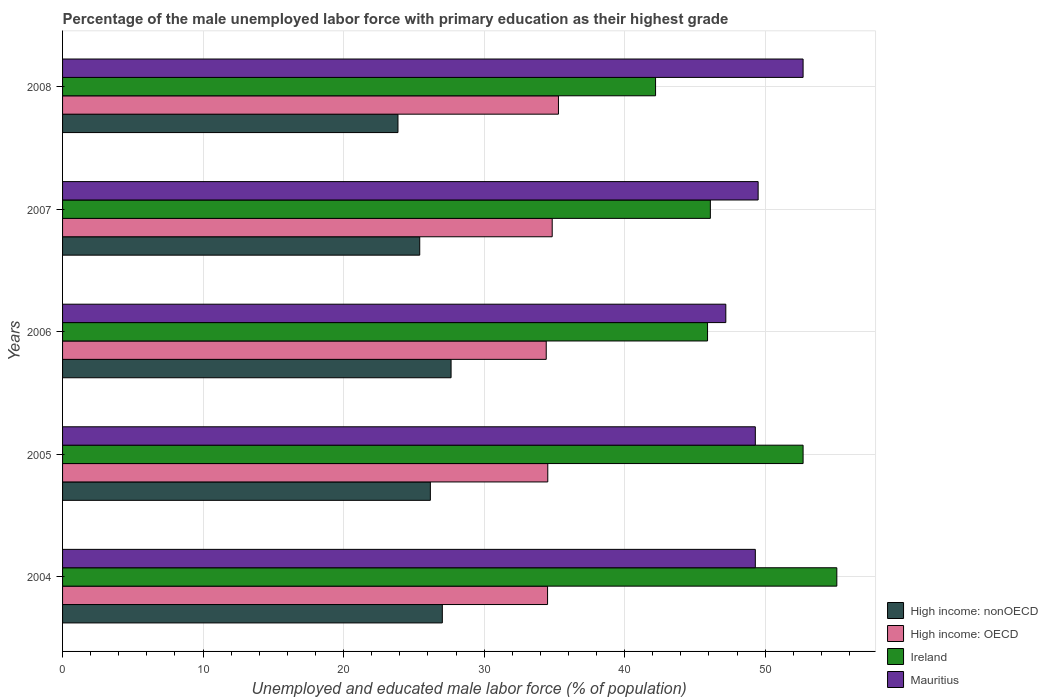How many groups of bars are there?
Keep it short and to the point. 5. Are the number of bars per tick equal to the number of legend labels?
Your answer should be compact. Yes. Are the number of bars on each tick of the Y-axis equal?
Provide a short and direct response. Yes. How many bars are there on the 1st tick from the top?
Your answer should be very brief. 4. What is the label of the 3rd group of bars from the top?
Provide a short and direct response. 2006. What is the percentage of the unemployed male labor force with primary education in High income: OECD in 2005?
Your answer should be compact. 34.53. Across all years, what is the maximum percentage of the unemployed male labor force with primary education in Ireland?
Your answer should be compact. 55.1. Across all years, what is the minimum percentage of the unemployed male labor force with primary education in High income: OECD?
Provide a short and direct response. 34.42. What is the total percentage of the unemployed male labor force with primary education in High income: OECD in the graph?
Offer a terse response. 173.6. What is the difference between the percentage of the unemployed male labor force with primary education in High income: OECD in 2007 and that in 2008?
Your response must be concise. -0.45. What is the difference between the percentage of the unemployed male labor force with primary education in Mauritius in 2006 and the percentage of the unemployed male labor force with primary education in High income: nonOECD in 2008?
Ensure brevity in your answer.  23.33. What is the average percentage of the unemployed male labor force with primary education in High income: nonOECD per year?
Keep it short and to the point. 26.03. In the year 2006, what is the difference between the percentage of the unemployed male labor force with primary education in Ireland and percentage of the unemployed male labor force with primary education in High income: nonOECD?
Offer a terse response. 18.25. What is the ratio of the percentage of the unemployed male labor force with primary education in High income: nonOECD in 2004 to that in 2007?
Ensure brevity in your answer.  1.06. Is the percentage of the unemployed male labor force with primary education in High income: nonOECD in 2006 less than that in 2007?
Provide a short and direct response. No. Is the difference between the percentage of the unemployed male labor force with primary education in Ireland in 2004 and 2008 greater than the difference between the percentage of the unemployed male labor force with primary education in High income: nonOECD in 2004 and 2008?
Ensure brevity in your answer.  Yes. What is the difference between the highest and the second highest percentage of the unemployed male labor force with primary education in Mauritius?
Provide a succinct answer. 3.2. What is the difference between the highest and the lowest percentage of the unemployed male labor force with primary education in High income: nonOECD?
Give a very brief answer. 3.78. In how many years, is the percentage of the unemployed male labor force with primary education in Ireland greater than the average percentage of the unemployed male labor force with primary education in Ireland taken over all years?
Make the answer very short. 2. Is it the case that in every year, the sum of the percentage of the unemployed male labor force with primary education in High income: nonOECD and percentage of the unemployed male labor force with primary education in Mauritius is greater than the sum of percentage of the unemployed male labor force with primary education in High income: OECD and percentage of the unemployed male labor force with primary education in Ireland?
Offer a terse response. Yes. What does the 4th bar from the top in 2006 represents?
Your answer should be compact. High income: nonOECD. What does the 2nd bar from the bottom in 2004 represents?
Your answer should be compact. High income: OECD. Are all the bars in the graph horizontal?
Your answer should be very brief. Yes. What is the difference between two consecutive major ticks on the X-axis?
Provide a succinct answer. 10. Does the graph contain grids?
Offer a terse response. Yes. How many legend labels are there?
Your answer should be compact. 4. What is the title of the graph?
Keep it short and to the point. Percentage of the male unemployed labor force with primary education as their highest grade. Does "Small states" appear as one of the legend labels in the graph?
Offer a terse response. No. What is the label or title of the X-axis?
Keep it short and to the point. Unemployed and educated male labor force (% of population). What is the Unemployed and educated male labor force (% of population) in High income: nonOECD in 2004?
Provide a short and direct response. 27.03. What is the Unemployed and educated male labor force (% of population) of High income: OECD in 2004?
Offer a terse response. 34.51. What is the Unemployed and educated male labor force (% of population) of Ireland in 2004?
Provide a short and direct response. 55.1. What is the Unemployed and educated male labor force (% of population) of Mauritius in 2004?
Give a very brief answer. 49.3. What is the Unemployed and educated male labor force (% of population) of High income: nonOECD in 2005?
Your answer should be very brief. 26.17. What is the Unemployed and educated male labor force (% of population) in High income: OECD in 2005?
Provide a short and direct response. 34.53. What is the Unemployed and educated male labor force (% of population) of Ireland in 2005?
Make the answer very short. 52.7. What is the Unemployed and educated male labor force (% of population) of Mauritius in 2005?
Offer a terse response. 49.3. What is the Unemployed and educated male labor force (% of population) in High income: nonOECD in 2006?
Keep it short and to the point. 27.65. What is the Unemployed and educated male labor force (% of population) of High income: OECD in 2006?
Your answer should be very brief. 34.42. What is the Unemployed and educated male labor force (% of population) in Ireland in 2006?
Provide a succinct answer. 45.9. What is the Unemployed and educated male labor force (% of population) of Mauritius in 2006?
Your response must be concise. 47.2. What is the Unemployed and educated male labor force (% of population) of High income: nonOECD in 2007?
Ensure brevity in your answer.  25.42. What is the Unemployed and educated male labor force (% of population) in High income: OECD in 2007?
Your answer should be very brief. 34.84. What is the Unemployed and educated male labor force (% of population) in Ireland in 2007?
Make the answer very short. 46.1. What is the Unemployed and educated male labor force (% of population) in Mauritius in 2007?
Ensure brevity in your answer.  49.5. What is the Unemployed and educated male labor force (% of population) of High income: nonOECD in 2008?
Offer a very short reply. 23.87. What is the Unemployed and educated male labor force (% of population) in High income: OECD in 2008?
Make the answer very short. 35.29. What is the Unemployed and educated male labor force (% of population) of Ireland in 2008?
Provide a short and direct response. 42.2. What is the Unemployed and educated male labor force (% of population) of Mauritius in 2008?
Offer a terse response. 52.7. Across all years, what is the maximum Unemployed and educated male labor force (% of population) of High income: nonOECD?
Your answer should be compact. 27.65. Across all years, what is the maximum Unemployed and educated male labor force (% of population) of High income: OECD?
Ensure brevity in your answer.  35.29. Across all years, what is the maximum Unemployed and educated male labor force (% of population) in Ireland?
Your answer should be compact. 55.1. Across all years, what is the maximum Unemployed and educated male labor force (% of population) in Mauritius?
Provide a short and direct response. 52.7. Across all years, what is the minimum Unemployed and educated male labor force (% of population) in High income: nonOECD?
Your response must be concise. 23.87. Across all years, what is the minimum Unemployed and educated male labor force (% of population) in High income: OECD?
Provide a short and direct response. 34.42. Across all years, what is the minimum Unemployed and educated male labor force (% of population) of Ireland?
Your response must be concise. 42.2. Across all years, what is the minimum Unemployed and educated male labor force (% of population) in Mauritius?
Your response must be concise. 47.2. What is the total Unemployed and educated male labor force (% of population) of High income: nonOECD in the graph?
Your answer should be compact. 130.13. What is the total Unemployed and educated male labor force (% of population) in High income: OECD in the graph?
Make the answer very short. 173.6. What is the total Unemployed and educated male labor force (% of population) of Ireland in the graph?
Your answer should be compact. 242. What is the total Unemployed and educated male labor force (% of population) of Mauritius in the graph?
Ensure brevity in your answer.  248. What is the difference between the Unemployed and educated male labor force (% of population) of High income: nonOECD in 2004 and that in 2005?
Your answer should be very brief. 0.85. What is the difference between the Unemployed and educated male labor force (% of population) in High income: OECD in 2004 and that in 2005?
Ensure brevity in your answer.  -0.02. What is the difference between the Unemployed and educated male labor force (% of population) in Mauritius in 2004 and that in 2005?
Your answer should be very brief. 0. What is the difference between the Unemployed and educated male labor force (% of population) of High income: nonOECD in 2004 and that in 2006?
Provide a succinct answer. -0.62. What is the difference between the Unemployed and educated male labor force (% of population) of High income: OECD in 2004 and that in 2006?
Offer a terse response. 0.09. What is the difference between the Unemployed and educated male labor force (% of population) of Ireland in 2004 and that in 2006?
Give a very brief answer. 9.2. What is the difference between the Unemployed and educated male labor force (% of population) in High income: nonOECD in 2004 and that in 2007?
Your answer should be compact. 1.61. What is the difference between the Unemployed and educated male labor force (% of population) in High income: OECD in 2004 and that in 2007?
Your response must be concise. -0.33. What is the difference between the Unemployed and educated male labor force (% of population) of Ireland in 2004 and that in 2007?
Make the answer very short. 9. What is the difference between the Unemployed and educated male labor force (% of population) of Mauritius in 2004 and that in 2007?
Offer a very short reply. -0.2. What is the difference between the Unemployed and educated male labor force (% of population) of High income: nonOECD in 2004 and that in 2008?
Ensure brevity in your answer.  3.16. What is the difference between the Unemployed and educated male labor force (% of population) of High income: OECD in 2004 and that in 2008?
Your answer should be compact. -0.78. What is the difference between the Unemployed and educated male labor force (% of population) in Ireland in 2004 and that in 2008?
Offer a terse response. 12.9. What is the difference between the Unemployed and educated male labor force (% of population) in Mauritius in 2004 and that in 2008?
Keep it short and to the point. -3.4. What is the difference between the Unemployed and educated male labor force (% of population) in High income: nonOECD in 2005 and that in 2006?
Your answer should be compact. -1.47. What is the difference between the Unemployed and educated male labor force (% of population) of High income: OECD in 2005 and that in 2006?
Make the answer very short. 0.11. What is the difference between the Unemployed and educated male labor force (% of population) in High income: nonOECD in 2005 and that in 2007?
Make the answer very short. 0.76. What is the difference between the Unemployed and educated male labor force (% of population) in High income: OECD in 2005 and that in 2007?
Ensure brevity in your answer.  -0.31. What is the difference between the Unemployed and educated male labor force (% of population) in Mauritius in 2005 and that in 2007?
Your answer should be very brief. -0.2. What is the difference between the Unemployed and educated male labor force (% of population) of High income: nonOECD in 2005 and that in 2008?
Your answer should be compact. 2.31. What is the difference between the Unemployed and educated male labor force (% of population) in High income: OECD in 2005 and that in 2008?
Your response must be concise. -0.76. What is the difference between the Unemployed and educated male labor force (% of population) in Mauritius in 2005 and that in 2008?
Provide a short and direct response. -3.4. What is the difference between the Unemployed and educated male labor force (% of population) in High income: nonOECD in 2006 and that in 2007?
Ensure brevity in your answer.  2.23. What is the difference between the Unemployed and educated male labor force (% of population) of High income: OECD in 2006 and that in 2007?
Offer a terse response. -0.42. What is the difference between the Unemployed and educated male labor force (% of population) of High income: nonOECD in 2006 and that in 2008?
Provide a succinct answer. 3.78. What is the difference between the Unemployed and educated male labor force (% of population) of High income: OECD in 2006 and that in 2008?
Provide a succinct answer. -0.87. What is the difference between the Unemployed and educated male labor force (% of population) in Ireland in 2006 and that in 2008?
Make the answer very short. 3.7. What is the difference between the Unemployed and educated male labor force (% of population) in Mauritius in 2006 and that in 2008?
Provide a short and direct response. -5.5. What is the difference between the Unemployed and educated male labor force (% of population) of High income: nonOECD in 2007 and that in 2008?
Provide a short and direct response. 1.55. What is the difference between the Unemployed and educated male labor force (% of population) in High income: OECD in 2007 and that in 2008?
Your answer should be compact. -0.45. What is the difference between the Unemployed and educated male labor force (% of population) in Ireland in 2007 and that in 2008?
Your answer should be compact. 3.9. What is the difference between the Unemployed and educated male labor force (% of population) of High income: nonOECD in 2004 and the Unemployed and educated male labor force (% of population) of High income: OECD in 2005?
Offer a terse response. -7.5. What is the difference between the Unemployed and educated male labor force (% of population) in High income: nonOECD in 2004 and the Unemployed and educated male labor force (% of population) in Ireland in 2005?
Offer a very short reply. -25.67. What is the difference between the Unemployed and educated male labor force (% of population) of High income: nonOECD in 2004 and the Unemployed and educated male labor force (% of population) of Mauritius in 2005?
Give a very brief answer. -22.27. What is the difference between the Unemployed and educated male labor force (% of population) in High income: OECD in 2004 and the Unemployed and educated male labor force (% of population) in Ireland in 2005?
Your answer should be compact. -18.19. What is the difference between the Unemployed and educated male labor force (% of population) of High income: OECD in 2004 and the Unemployed and educated male labor force (% of population) of Mauritius in 2005?
Offer a very short reply. -14.79. What is the difference between the Unemployed and educated male labor force (% of population) of Ireland in 2004 and the Unemployed and educated male labor force (% of population) of Mauritius in 2005?
Ensure brevity in your answer.  5.8. What is the difference between the Unemployed and educated male labor force (% of population) in High income: nonOECD in 2004 and the Unemployed and educated male labor force (% of population) in High income: OECD in 2006?
Ensure brevity in your answer.  -7.39. What is the difference between the Unemployed and educated male labor force (% of population) of High income: nonOECD in 2004 and the Unemployed and educated male labor force (% of population) of Ireland in 2006?
Make the answer very short. -18.87. What is the difference between the Unemployed and educated male labor force (% of population) of High income: nonOECD in 2004 and the Unemployed and educated male labor force (% of population) of Mauritius in 2006?
Your answer should be very brief. -20.17. What is the difference between the Unemployed and educated male labor force (% of population) of High income: OECD in 2004 and the Unemployed and educated male labor force (% of population) of Ireland in 2006?
Your response must be concise. -11.39. What is the difference between the Unemployed and educated male labor force (% of population) of High income: OECD in 2004 and the Unemployed and educated male labor force (% of population) of Mauritius in 2006?
Offer a terse response. -12.69. What is the difference between the Unemployed and educated male labor force (% of population) of Ireland in 2004 and the Unemployed and educated male labor force (% of population) of Mauritius in 2006?
Your answer should be very brief. 7.9. What is the difference between the Unemployed and educated male labor force (% of population) of High income: nonOECD in 2004 and the Unemployed and educated male labor force (% of population) of High income: OECD in 2007?
Your answer should be very brief. -7.82. What is the difference between the Unemployed and educated male labor force (% of population) in High income: nonOECD in 2004 and the Unemployed and educated male labor force (% of population) in Ireland in 2007?
Your response must be concise. -19.07. What is the difference between the Unemployed and educated male labor force (% of population) of High income: nonOECD in 2004 and the Unemployed and educated male labor force (% of population) of Mauritius in 2007?
Offer a very short reply. -22.47. What is the difference between the Unemployed and educated male labor force (% of population) in High income: OECD in 2004 and the Unemployed and educated male labor force (% of population) in Ireland in 2007?
Your response must be concise. -11.59. What is the difference between the Unemployed and educated male labor force (% of population) of High income: OECD in 2004 and the Unemployed and educated male labor force (% of population) of Mauritius in 2007?
Offer a terse response. -14.99. What is the difference between the Unemployed and educated male labor force (% of population) in High income: nonOECD in 2004 and the Unemployed and educated male labor force (% of population) in High income: OECD in 2008?
Your answer should be very brief. -8.26. What is the difference between the Unemployed and educated male labor force (% of population) of High income: nonOECD in 2004 and the Unemployed and educated male labor force (% of population) of Ireland in 2008?
Provide a succinct answer. -15.17. What is the difference between the Unemployed and educated male labor force (% of population) in High income: nonOECD in 2004 and the Unemployed and educated male labor force (% of population) in Mauritius in 2008?
Your response must be concise. -25.67. What is the difference between the Unemployed and educated male labor force (% of population) in High income: OECD in 2004 and the Unemployed and educated male labor force (% of population) in Ireland in 2008?
Provide a succinct answer. -7.69. What is the difference between the Unemployed and educated male labor force (% of population) of High income: OECD in 2004 and the Unemployed and educated male labor force (% of population) of Mauritius in 2008?
Your response must be concise. -18.19. What is the difference between the Unemployed and educated male labor force (% of population) in High income: nonOECD in 2005 and the Unemployed and educated male labor force (% of population) in High income: OECD in 2006?
Offer a terse response. -8.25. What is the difference between the Unemployed and educated male labor force (% of population) in High income: nonOECD in 2005 and the Unemployed and educated male labor force (% of population) in Ireland in 2006?
Provide a succinct answer. -19.73. What is the difference between the Unemployed and educated male labor force (% of population) of High income: nonOECD in 2005 and the Unemployed and educated male labor force (% of population) of Mauritius in 2006?
Offer a very short reply. -21.03. What is the difference between the Unemployed and educated male labor force (% of population) of High income: OECD in 2005 and the Unemployed and educated male labor force (% of population) of Ireland in 2006?
Make the answer very short. -11.37. What is the difference between the Unemployed and educated male labor force (% of population) of High income: OECD in 2005 and the Unemployed and educated male labor force (% of population) of Mauritius in 2006?
Ensure brevity in your answer.  -12.67. What is the difference between the Unemployed and educated male labor force (% of population) in High income: nonOECD in 2005 and the Unemployed and educated male labor force (% of population) in High income: OECD in 2007?
Offer a very short reply. -8.67. What is the difference between the Unemployed and educated male labor force (% of population) in High income: nonOECD in 2005 and the Unemployed and educated male labor force (% of population) in Ireland in 2007?
Give a very brief answer. -19.93. What is the difference between the Unemployed and educated male labor force (% of population) of High income: nonOECD in 2005 and the Unemployed and educated male labor force (% of population) of Mauritius in 2007?
Your answer should be compact. -23.33. What is the difference between the Unemployed and educated male labor force (% of population) in High income: OECD in 2005 and the Unemployed and educated male labor force (% of population) in Ireland in 2007?
Make the answer very short. -11.57. What is the difference between the Unemployed and educated male labor force (% of population) of High income: OECD in 2005 and the Unemployed and educated male labor force (% of population) of Mauritius in 2007?
Provide a succinct answer. -14.97. What is the difference between the Unemployed and educated male labor force (% of population) of High income: nonOECD in 2005 and the Unemployed and educated male labor force (% of population) of High income: OECD in 2008?
Ensure brevity in your answer.  -9.12. What is the difference between the Unemployed and educated male labor force (% of population) of High income: nonOECD in 2005 and the Unemployed and educated male labor force (% of population) of Ireland in 2008?
Your answer should be very brief. -16.03. What is the difference between the Unemployed and educated male labor force (% of population) of High income: nonOECD in 2005 and the Unemployed and educated male labor force (% of population) of Mauritius in 2008?
Keep it short and to the point. -26.53. What is the difference between the Unemployed and educated male labor force (% of population) of High income: OECD in 2005 and the Unemployed and educated male labor force (% of population) of Ireland in 2008?
Your response must be concise. -7.67. What is the difference between the Unemployed and educated male labor force (% of population) in High income: OECD in 2005 and the Unemployed and educated male labor force (% of population) in Mauritius in 2008?
Your answer should be very brief. -18.17. What is the difference between the Unemployed and educated male labor force (% of population) of Ireland in 2005 and the Unemployed and educated male labor force (% of population) of Mauritius in 2008?
Your answer should be very brief. 0. What is the difference between the Unemployed and educated male labor force (% of population) of High income: nonOECD in 2006 and the Unemployed and educated male labor force (% of population) of High income: OECD in 2007?
Your answer should be very brief. -7.2. What is the difference between the Unemployed and educated male labor force (% of population) in High income: nonOECD in 2006 and the Unemployed and educated male labor force (% of population) in Ireland in 2007?
Make the answer very short. -18.45. What is the difference between the Unemployed and educated male labor force (% of population) in High income: nonOECD in 2006 and the Unemployed and educated male labor force (% of population) in Mauritius in 2007?
Keep it short and to the point. -21.85. What is the difference between the Unemployed and educated male labor force (% of population) of High income: OECD in 2006 and the Unemployed and educated male labor force (% of population) of Ireland in 2007?
Offer a very short reply. -11.68. What is the difference between the Unemployed and educated male labor force (% of population) in High income: OECD in 2006 and the Unemployed and educated male labor force (% of population) in Mauritius in 2007?
Your response must be concise. -15.08. What is the difference between the Unemployed and educated male labor force (% of population) of High income: nonOECD in 2006 and the Unemployed and educated male labor force (% of population) of High income: OECD in 2008?
Provide a short and direct response. -7.64. What is the difference between the Unemployed and educated male labor force (% of population) in High income: nonOECD in 2006 and the Unemployed and educated male labor force (% of population) in Ireland in 2008?
Your answer should be very brief. -14.55. What is the difference between the Unemployed and educated male labor force (% of population) in High income: nonOECD in 2006 and the Unemployed and educated male labor force (% of population) in Mauritius in 2008?
Offer a very short reply. -25.05. What is the difference between the Unemployed and educated male labor force (% of population) of High income: OECD in 2006 and the Unemployed and educated male labor force (% of population) of Ireland in 2008?
Keep it short and to the point. -7.78. What is the difference between the Unemployed and educated male labor force (% of population) of High income: OECD in 2006 and the Unemployed and educated male labor force (% of population) of Mauritius in 2008?
Keep it short and to the point. -18.28. What is the difference between the Unemployed and educated male labor force (% of population) in Ireland in 2006 and the Unemployed and educated male labor force (% of population) in Mauritius in 2008?
Keep it short and to the point. -6.8. What is the difference between the Unemployed and educated male labor force (% of population) in High income: nonOECD in 2007 and the Unemployed and educated male labor force (% of population) in High income: OECD in 2008?
Give a very brief answer. -9.87. What is the difference between the Unemployed and educated male labor force (% of population) in High income: nonOECD in 2007 and the Unemployed and educated male labor force (% of population) in Ireland in 2008?
Provide a short and direct response. -16.78. What is the difference between the Unemployed and educated male labor force (% of population) in High income: nonOECD in 2007 and the Unemployed and educated male labor force (% of population) in Mauritius in 2008?
Provide a short and direct response. -27.28. What is the difference between the Unemployed and educated male labor force (% of population) in High income: OECD in 2007 and the Unemployed and educated male labor force (% of population) in Ireland in 2008?
Your answer should be very brief. -7.36. What is the difference between the Unemployed and educated male labor force (% of population) in High income: OECD in 2007 and the Unemployed and educated male labor force (% of population) in Mauritius in 2008?
Make the answer very short. -17.86. What is the difference between the Unemployed and educated male labor force (% of population) in Ireland in 2007 and the Unemployed and educated male labor force (% of population) in Mauritius in 2008?
Give a very brief answer. -6.6. What is the average Unemployed and educated male labor force (% of population) of High income: nonOECD per year?
Make the answer very short. 26.03. What is the average Unemployed and educated male labor force (% of population) in High income: OECD per year?
Your response must be concise. 34.72. What is the average Unemployed and educated male labor force (% of population) of Ireland per year?
Your answer should be very brief. 48.4. What is the average Unemployed and educated male labor force (% of population) in Mauritius per year?
Offer a very short reply. 49.6. In the year 2004, what is the difference between the Unemployed and educated male labor force (% of population) of High income: nonOECD and Unemployed and educated male labor force (% of population) of High income: OECD?
Offer a very short reply. -7.49. In the year 2004, what is the difference between the Unemployed and educated male labor force (% of population) of High income: nonOECD and Unemployed and educated male labor force (% of population) of Ireland?
Provide a succinct answer. -28.07. In the year 2004, what is the difference between the Unemployed and educated male labor force (% of population) of High income: nonOECD and Unemployed and educated male labor force (% of population) of Mauritius?
Offer a terse response. -22.27. In the year 2004, what is the difference between the Unemployed and educated male labor force (% of population) in High income: OECD and Unemployed and educated male labor force (% of population) in Ireland?
Your answer should be compact. -20.59. In the year 2004, what is the difference between the Unemployed and educated male labor force (% of population) of High income: OECD and Unemployed and educated male labor force (% of population) of Mauritius?
Your answer should be compact. -14.79. In the year 2005, what is the difference between the Unemployed and educated male labor force (% of population) in High income: nonOECD and Unemployed and educated male labor force (% of population) in High income: OECD?
Offer a very short reply. -8.36. In the year 2005, what is the difference between the Unemployed and educated male labor force (% of population) in High income: nonOECD and Unemployed and educated male labor force (% of population) in Ireland?
Give a very brief answer. -26.53. In the year 2005, what is the difference between the Unemployed and educated male labor force (% of population) in High income: nonOECD and Unemployed and educated male labor force (% of population) in Mauritius?
Offer a terse response. -23.13. In the year 2005, what is the difference between the Unemployed and educated male labor force (% of population) of High income: OECD and Unemployed and educated male labor force (% of population) of Ireland?
Offer a very short reply. -18.17. In the year 2005, what is the difference between the Unemployed and educated male labor force (% of population) in High income: OECD and Unemployed and educated male labor force (% of population) in Mauritius?
Make the answer very short. -14.77. In the year 2006, what is the difference between the Unemployed and educated male labor force (% of population) in High income: nonOECD and Unemployed and educated male labor force (% of population) in High income: OECD?
Provide a short and direct response. -6.77. In the year 2006, what is the difference between the Unemployed and educated male labor force (% of population) in High income: nonOECD and Unemployed and educated male labor force (% of population) in Ireland?
Provide a succinct answer. -18.25. In the year 2006, what is the difference between the Unemployed and educated male labor force (% of population) in High income: nonOECD and Unemployed and educated male labor force (% of population) in Mauritius?
Your answer should be compact. -19.55. In the year 2006, what is the difference between the Unemployed and educated male labor force (% of population) in High income: OECD and Unemployed and educated male labor force (% of population) in Ireland?
Offer a very short reply. -11.48. In the year 2006, what is the difference between the Unemployed and educated male labor force (% of population) in High income: OECD and Unemployed and educated male labor force (% of population) in Mauritius?
Your answer should be very brief. -12.78. In the year 2006, what is the difference between the Unemployed and educated male labor force (% of population) in Ireland and Unemployed and educated male labor force (% of population) in Mauritius?
Give a very brief answer. -1.3. In the year 2007, what is the difference between the Unemployed and educated male labor force (% of population) of High income: nonOECD and Unemployed and educated male labor force (% of population) of High income: OECD?
Your answer should be very brief. -9.43. In the year 2007, what is the difference between the Unemployed and educated male labor force (% of population) in High income: nonOECD and Unemployed and educated male labor force (% of population) in Ireland?
Ensure brevity in your answer.  -20.68. In the year 2007, what is the difference between the Unemployed and educated male labor force (% of population) in High income: nonOECD and Unemployed and educated male labor force (% of population) in Mauritius?
Your answer should be very brief. -24.08. In the year 2007, what is the difference between the Unemployed and educated male labor force (% of population) of High income: OECD and Unemployed and educated male labor force (% of population) of Ireland?
Ensure brevity in your answer.  -11.26. In the year 2007, what is the difference between the Unemployed and educated male labor force (% of population) in High income: OECD and Unemployed and educated male labor force (% of population) in Mauritius?
Make the answer very short. -14.65. In the year 2007, what is the difference between the Unemployed and educated male labor force (% of population) in Ireland and Unemployed and educated male labor force (% of population) in Mauritius?
Your answer should be compact. -3.4. In the year 2008, what is the difference between the Unemployed and educated male labor force (% of population) in High income: nonOECD and Unemployed and educated male labor force (% of population) in High income: OECD?
Keep it short and to the point. -11.42. In the year 2008, what is the difference between the Unemployed and educated male labor force (% of population) in High income: nonOECD and Unemployed and educated male labor force (% of population) in Ireland?
Your answer should be very brief. -18.33. In the year 2008, what is the difference between the Unemployed and educated male labor force (% of population) in High income: nonOECD and Unemployed and educated male labor force (% of population) in Mauritius?
Offer a terse response. -28.83. In the year 2008, what is the difference between the Unemployed and educated male labor force (% of population) of High income: OECD and Unemployed and educated male labor force (% of population) of Ireland?
Give a very brief answer. -6.91. In the year 2008, what is the difference between the Unemployed and educated male labor force (% of population) in High income: OECD and Unemployed and educated male labor force (% of population) in Mauritius?
Provide a succinct answer. -17.41. What is the ratio of the Unemployed and educated male labor force (% of population) in High income: nonOECD in 2004 to that in 2005?
Provide a succinct answer. 1.03. What is the ratio of the Unemployed and educated male labor force (% of population) in High income: OECD in 2004 to that in 2005?
Give a very brief answer. 1. What is the ratio of the Unemployed and educated male labor force (% of population) of Ireland in 2004 to that in 2005?
Give a very brief answer. 1.05. What is the ratio of the Unemployed and educated male labor force (% of population) of Mauritius in 2004 to that in 2005?
Ensure brevity in your answer.  1. What is the ratio of the Unemployed and educated male labor force (% of population) of High income: nonOECD in 2004 to that in 2006?
Offer a very short reply. 0.98. What is the ratio of the Unemployed and educated male labor force (% of population) of High income: OECD in 2004 to that in 2006?
Your answer should be very brief. 1. What is the ratio of the Unemployed and educated male labor force (% of population) in Ireland in 2004 to that in 2006?
Keep it short and to the point. 1.2. What is the ratio of the Unemployed and educated male labor force (% of population) in Mauritius in 2004 to that in 2006?
Ensure brevity in your answer.  1.04. What is the ratio of the Unemployed and educated male labor force (% of population) in High income: nonOECD in 2004 to that in 2007?
Offer a very short reply. 1.06. What is the ratio of the Unemployed and educated male labor force (% of population) in Ireland in 2004 to that in 2007?
Your answer should be compact. 1.2. What is the ratio of the Unemployed and educated male labor force (% of population) of Mauritius in 2004 to that in 2007?
Provide a short and direct response. 1. What is the ratio of the Unemployed and educated male labor force (% of population) in High income: nonOECD in 2004 to that in 2008?
Your answer should be compact. 1.13. What is the ratio of the Unemployed and educated male labor force (% of population) in High income: OECD in 2004 to that in 2008?
Keep it short and to the point. 0.98. What is the ratio of the Unemployed and educated male labor force (% of population) of Ireland in 2004 to that in 2008?
Ensure brevity in your answer.  1.31. What is the ratio of the Unemployed and educated male labor force (% of population) in Mauritius in 2004 to that in 2008?
Give a very brief answer. 0.94. What is the ratio of the Unemployed and educated male labor force (% of population) in High income: nonOECD in 2005 to that in 2006?
Your answer should be compact. 0.95. What is the ratio of the Unemployed and educated male labor force (% of population) of High income: OECD in 2005 to that in 2006?
Provide a succinct answer. 1. What is the ratio of the Unemployed and educated male labor force (% of population) in Ireland in 2005 to that in 2006?
Provide a short and direct response. 1.15. What is the ratio of the Unemployed and educated male labor force (% of population) in Mauritius in 2005 to that in 2006?
Keep it short and to the point. 1.04. What is the ratio of the Unemployed and educated male labor force (% of population) of High income: nonOECD in 2005 to that in 2007?
Ensure brevity in your answer.  1.03. What is the ratio of the Unemployed and educated male labor force (% of population) in Ireland in 2005 to that in 2007?
Your response must be concise. 1.14. What is the ratio of the Unemployed and educated male labor force (% of population) in Mauritius in 2005 to that in 2007?
Keep it short and to the point. 1. What is the ratio of the Unemployed and educated male labor force (% of population) in High income: nonOECD in 2005 to that in 2008?
Keep it short and to the point. 1.1. What is the ratio of the Unemployed and educated male labor force (% of population) in High income: OECD in 2005 to that in 2008?
Provide a short and direct response. 0.98. What is the ratio of the Unemployed and educated male labor force (% of population) of Ireland in 2005 to that in 2008?
Provide a succinct answer. 1.25. What is the ratio of the Unemployed and educated male labor force (% of population) in Mauritius in 2005 to that in 2008?
Give a very brief answer. 0.94. What is the ratio of the Unemployed and educated male labor force (% of population) of High income: nonOECD in 2006 to that in 2007?
Ensure brevity in your answer.  1.09. What is the ratio of the Unemployed and educated male labor force (% of population) of Ireland in 2006 to that in 2007?
Your answer should be very brief. 1. What is the ratio of the Unemployed and educated male labor force (% of population) in Mauritius in 2006 to that in 2007?
Provide a short and direct response. 0.95. What is the ratio of the Unemployed and educated male labor force (% of population) in High income: nonOECD in 2006 to that in 2008?
Ensure brevity in your answer.  1.16. What is the ratio of the Unemployed and educated male labor force (% of population) in High income: OECD in 2006 to that in 2008?
Keep it short and to the point. 0.98. What is the ratio of the Unemployed and educated male labor force (% of population) of Ireland in 2006 to that in 2008?
Ensure brevity in your answer.  1.09. What is the ratio of the Unemployed and educated male labor force (% of population) of Mauritius in 2006 to that in 2008?
Provide a succinct answer. 0.9. What is the ratio of the Unemployed and educated male labor force (% of population) of High income: nonOECD in 2007 to that in 2008?
Offer a very short reply. 1.06. What is the ratio of the Unemployed and educated male labor force (% of population) of High income: OECD in 2007 to that in 2008?
Make the answer very short. 0.99. What is the ratio of the Unemployed and educated male labor force (% of population) of Ireland in 2007 to that in 2008?
Provide a short and direct response. 1.09. What is the ratio of the Unemployed and educated male labor force (% of population) in Mauritius in 2007 to that in 2008?
Your answer should be compact. 0.94. What is the difference between the highest and the second highest Unemployed and educated male labor force (% of population) of High income: nonOECD?
Give a very brief answer. 0.62. What is the difference between the highest and the second highest Unemployed and educated male labor force (% of population) of High income: OECD?
Your response must be concise. 0.45. What is the difference between the highest and the second highest Unemployed and educated male labor force (% of population) in Mauritius?
Ensure brevity in your answer.  3.2. What is the difference between the highest and the lowest Unemployed and educated male labor force (% of population) in High income: nonOECD?
Give a very brief answer. 3.78. What is the difference between the highest and the lowest Unemployed and educated male labor force (% of population) in High income: OECD?
Ensure brevity in your answer.  0.87. 